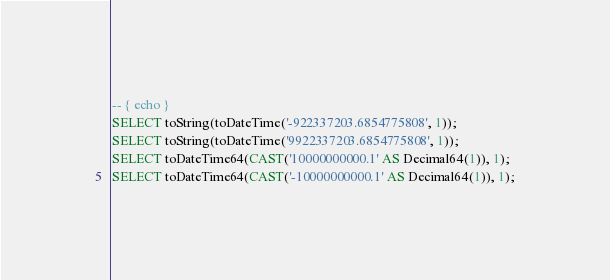<code> <loc_0><loc_0><loc_500><loc_500><_SQL_>-- { echo }
SELECT toString(toDateTime('-922337203.6854775808', 1));
SELECT toString(toDateTime('9922337203.6854775808', 1));
SELECT toDateTime64(CAST('10000000000.1' AS Decimal64(1)), 1);
SELECT toDateTime64(CAST('-10000000000.1' AS Decimal64(1)), 1);
</code> 